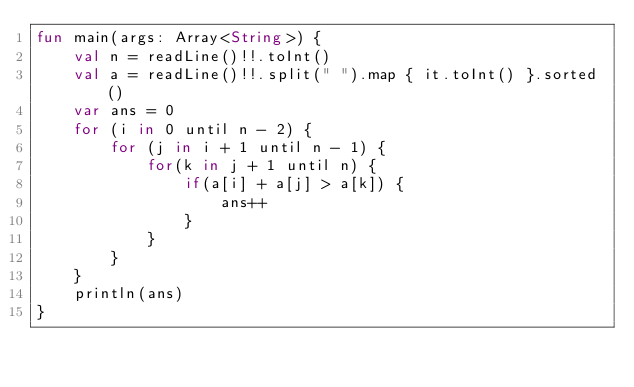Convert code to text. <code><loc_0><loc_0><loc_500><loc_500><_Kotlin_>fun main(args: Array<String>) {
    val n = readLine()!!.toInt()
    val a = readLine()!!.split(" ").map { it.toInt() }.sorted()
    var ans = 0
    for (i in 0 until n - 2) {
        for (j in i + 1 until n - 1) {
            for(k in j + 1 until n) {
                if(a[i] + a[j] > a[k]) {
                    ans++
                }
            }
        }
    }
    println(ans)
}</code> 